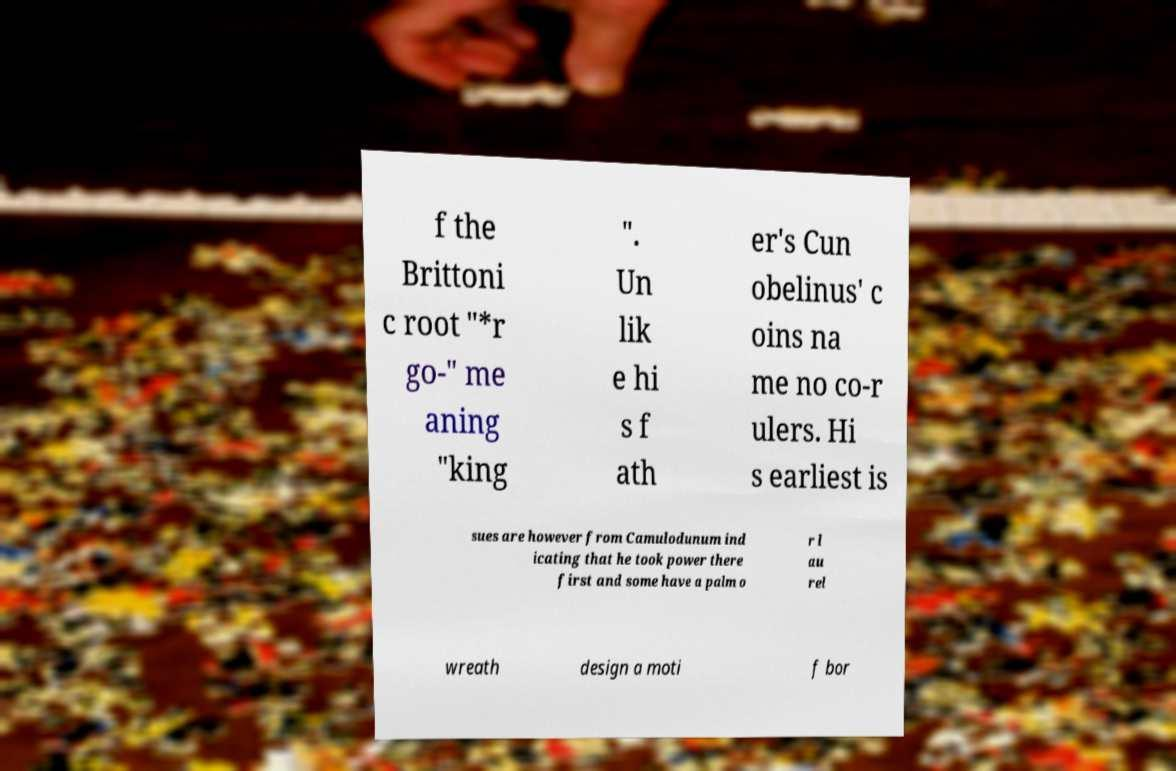Please identify and transcribe the text found in this image. f the Brittoni c root "*r go-" me aning "king ". Un lik e hi s f ath er's Cun obelinus' c oins na me no co-r ulers. Hi s earliest is sues are however from Camulodunum ind icating that he took power there first and some have a palm o r l au rel wreath design a moti f bor 